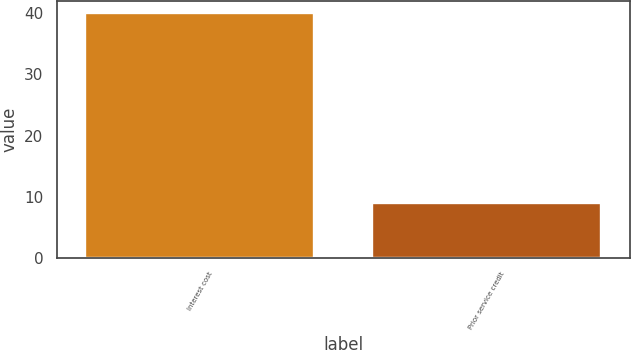Convert chart to OTSL. <chart><loc_0><loc_0><loc_500><loc_500><bar_chart><fcel>Interest cost<fcel>Prior service credit<nl><fcel>40<fcel>9<nl></chart> 